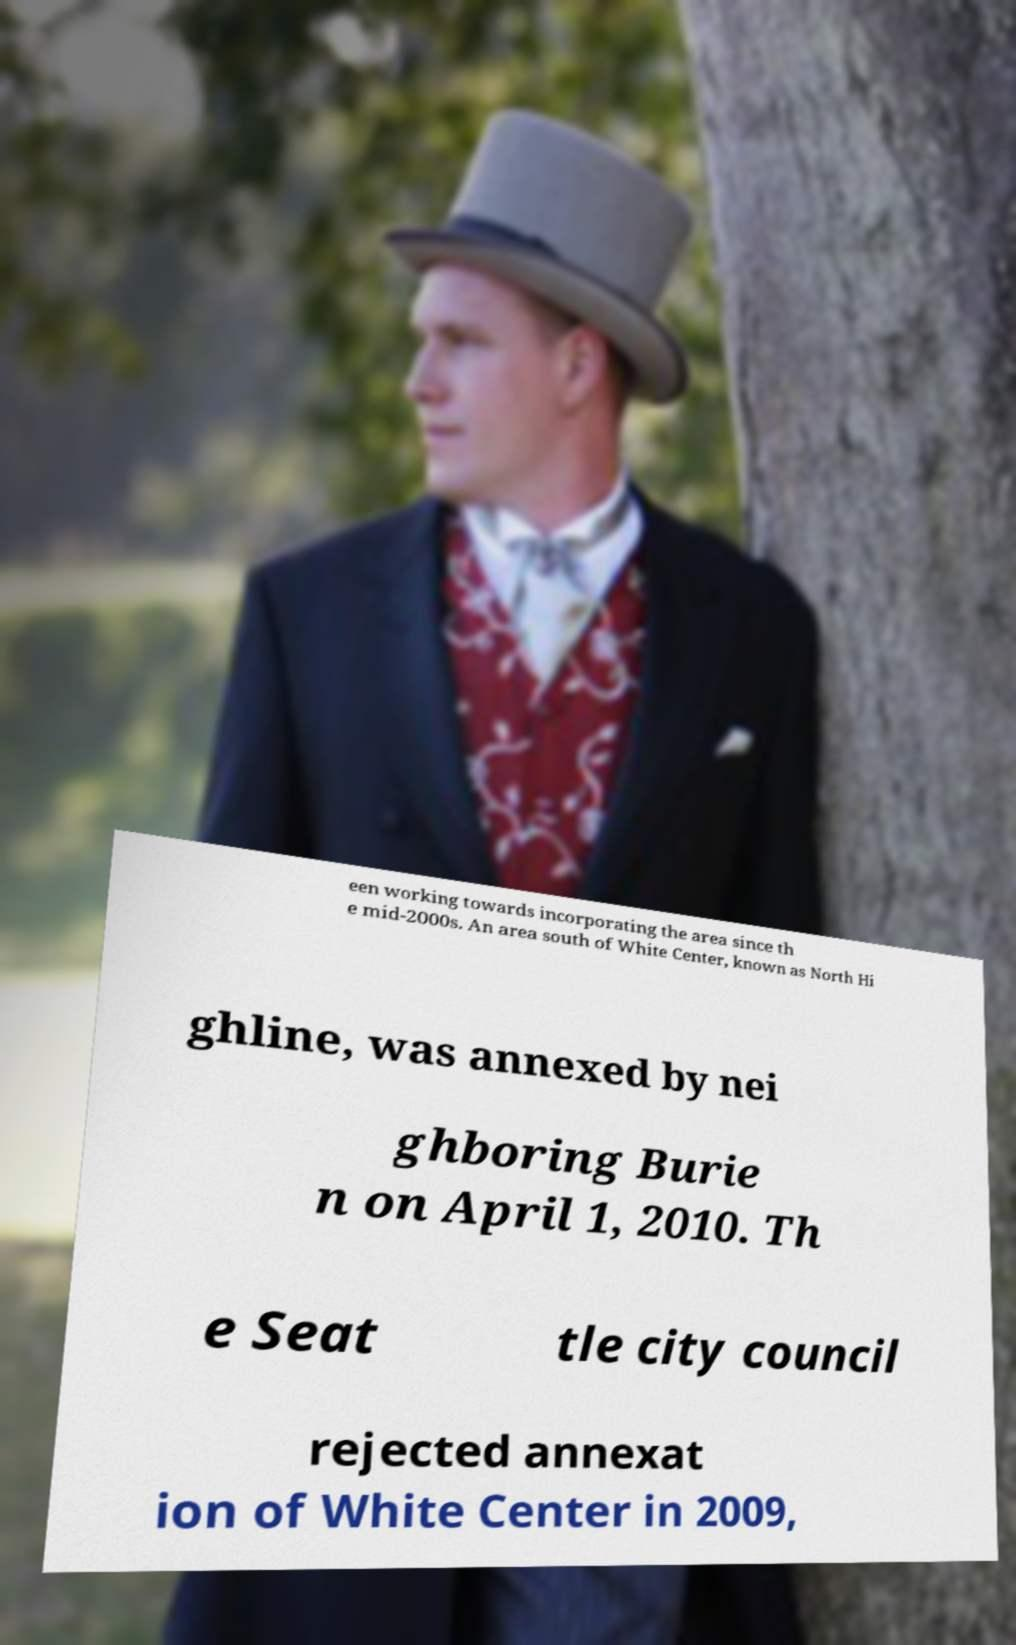Please read and relay the text visible in this image. What does it say? een working towards incorporating the area since th e mid-2000s. An area south of White Center, known as North Hi ghline, was annexed by nei ghboring Burie n on April 1, 2010. Th e Seat tle city council rejected annexat ion of White Center in 2009, 